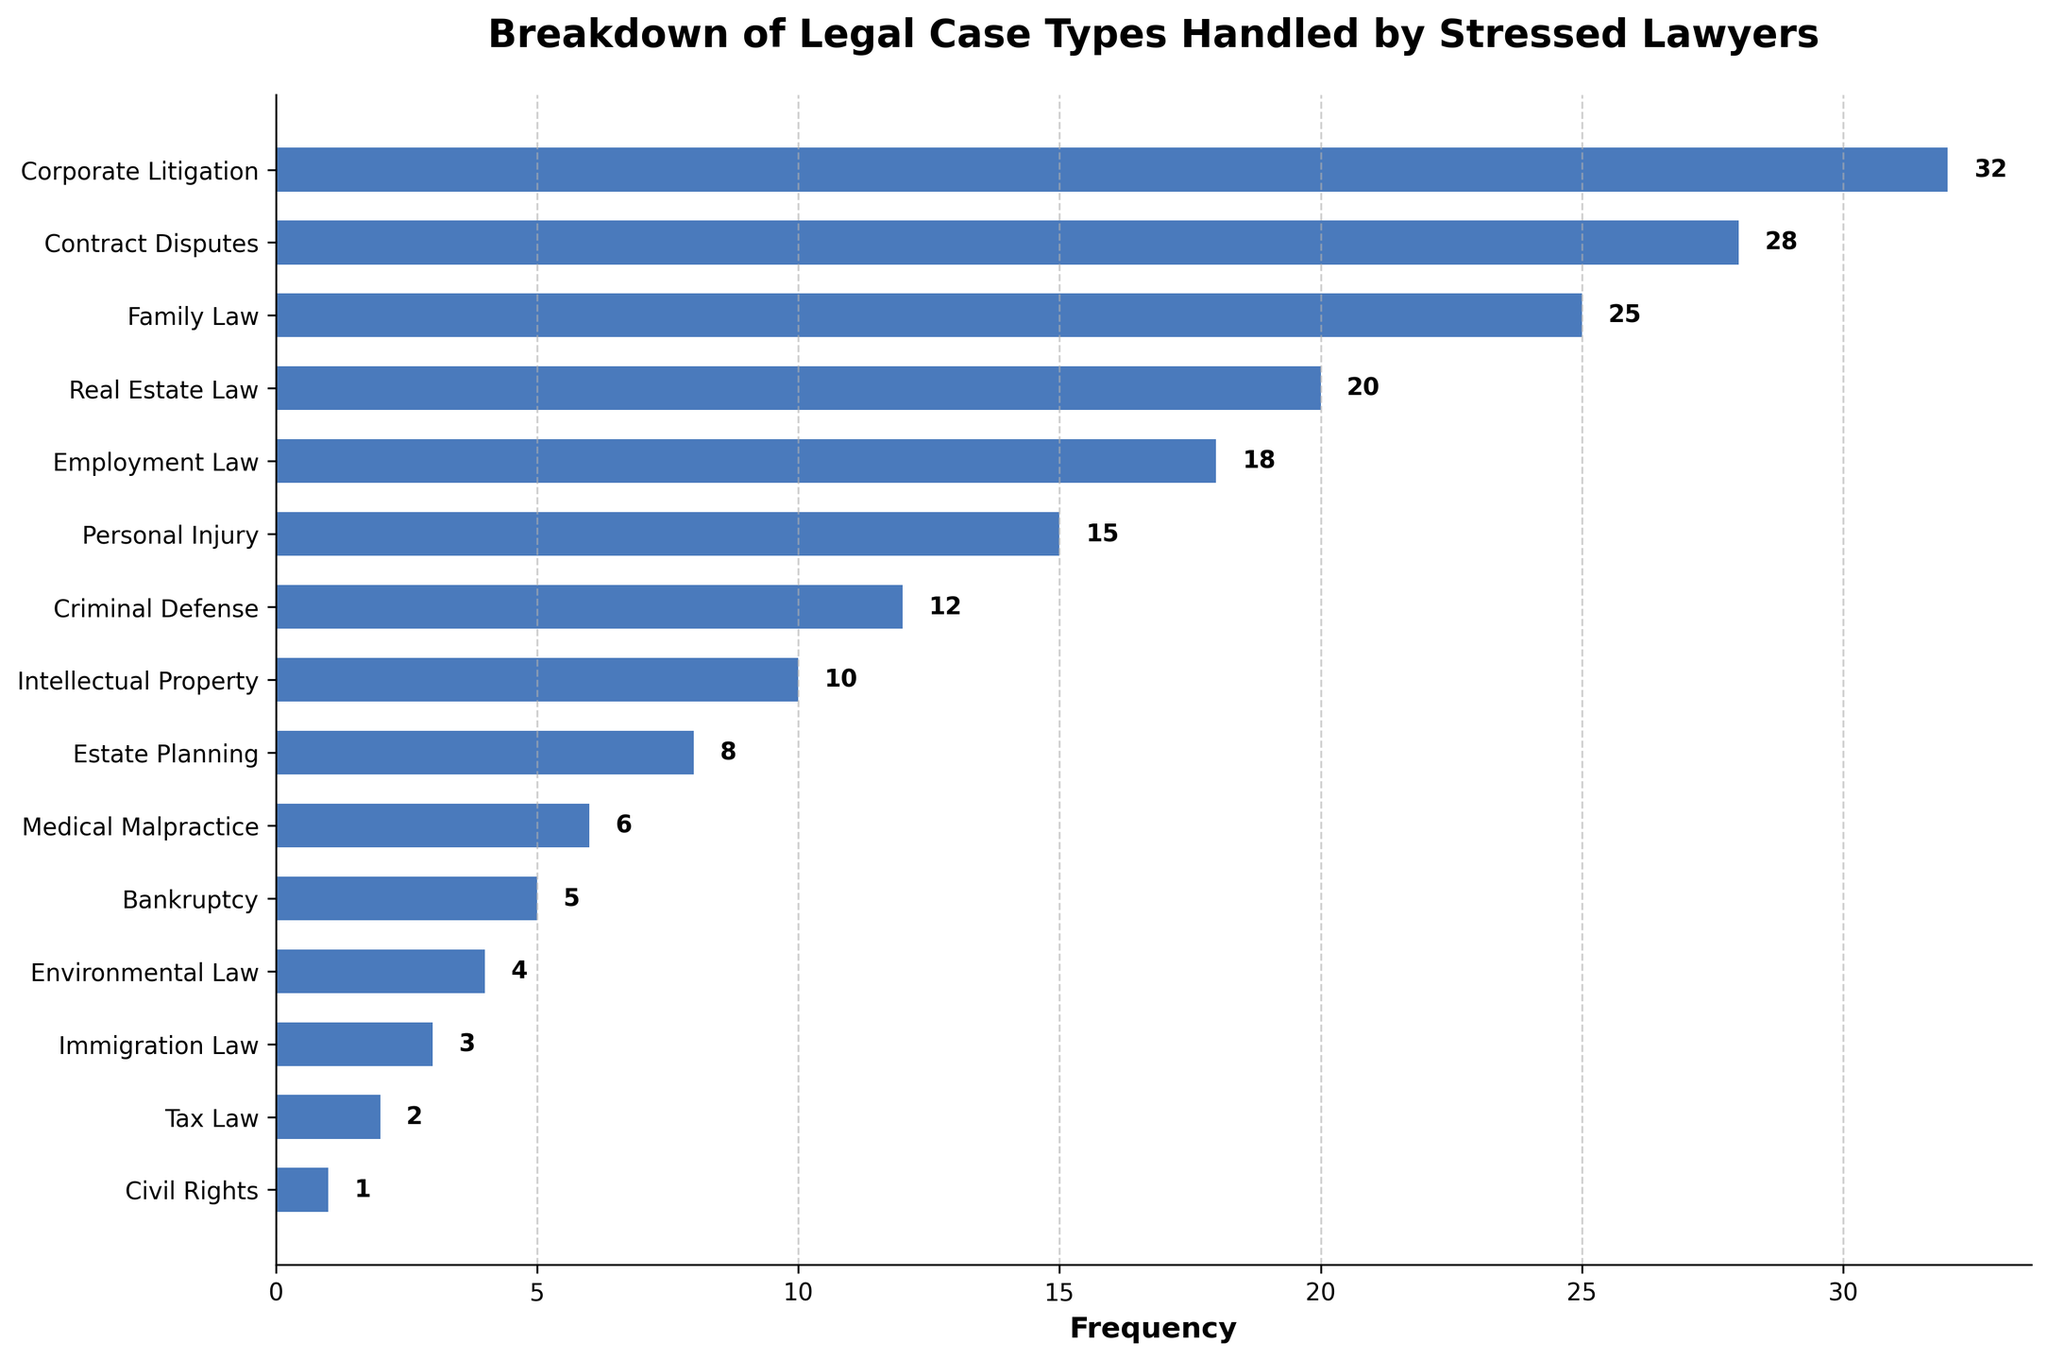What is the most common type of legal case handled by stressed lawyers? The most common type of legal case is identified by the bar with the highest frequency. In the chart, the bar for "Corporate Litigation" is the highest.
Answer: Corporate Litigation What is the frequency difference between Corporate Litigation and Contract Disputes? The frequency for Corporate Litigation is 32, and for Contract Disputes, it is 28. The difference is 32 - 28.
Answer: 4 What is the combined frequency of Family Law, Employment Law, and Personal Injury cases? The frequency for Family Law is 25, Employment Law is 18, and Personal Injury is 15. The combined frequency is 25 + 18 + 15.
Answer: 58 Which case type has the least frequency and what is that frequency? The least frequent case type can be found by identifying the shortest bar. The shortest bar is for Civil Rights with a frequency of 1.
Answer: Civil Rights, 1 How many case types have a frequency greater than 15? Visual inspection of the bars shows that the following case types have frequencies greater than 15: Corporate Litigation (32), Contract Disputes (28), Family Law (25), Real Estate Law (20), and Employment Law (18). Count these case types.
Answer: 5 Is there any case type with a frequency equal to 10? If yes, name it. Look for a bar that ends at the value 10 on the x-axis. The bar corresponding to Intellectual Property has a frequency of 10.
Answer: Yes, Intellectual Property What is the median frequency of the legal case types listed? To find the median, list all frequencies in ascending order: 1, 2, 3, 4, 5, 6, 8, 10, 12, 15, 18, 20, 25, 28, 32. The median is the middle value of this ordered list.
Answer: 12 Which case type has 15 cases handled and is represented by a bar that is 8th from the top? Count the bars from the top to find the 8th bar. The bars in order are Corporate Litigation, Contract Disputes, Family Law, Real Estate Law, Employment Law, Personal Injury, Criminal Defense, then Intellectual Property. The 8th bar corresponds to Personal Injury.
Answer: Personal Injury What is the average frequency of Environmental Law, Immigration Law, and Tax Law cases combined? The frequencies are 4 for Environmental Law, 3 for Immigration Law, and 2 for Tax Law. Sum these values and divide by the number of case types (3). (4 + 3 + 2) / 3 = 3.
Answer: 3 